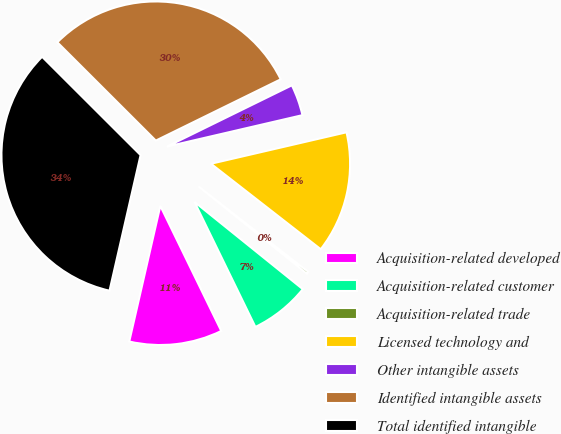<chart> <loc_0><loc_0><loc_500><loc_500><pie_chart><fcel>Acquisition-related developed<fcel>Acquisition-related customer<fcel>Acquisition-related trade<fcel>Licensed technology and<fcel>Other intangible assets<fcel>Identified intangible assets<fcel>Total identified intangible<nl><fcel>10.8%<fcel>6.99%<fcel>0.26%<fcel>14.16%<fcel>3.63%<fcel>30.25%<fcel>33.9%<nl></chart> 